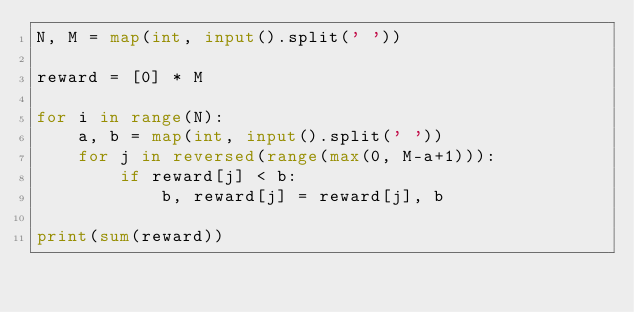<code> <loc_0><loc_0><loc_500><loc_500><_Python_>N, M = map(int, input().split(' '))

reward = [0] * M

for i in range(N):
    a, b = map(int, input().split(' '))
    for j in reversed(range(max(0, M-a+1))):
        if reward[j] < b:
            b, reward[j] = reward[j], b

print(sum(reward))
</code> 